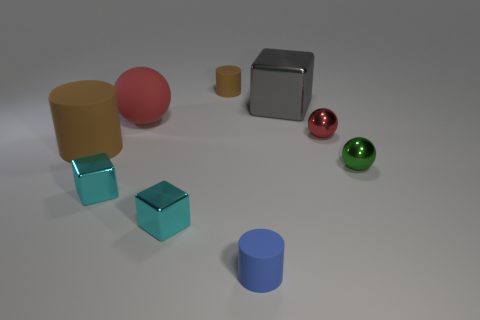Are there more things that are to the left of the red metal sphere than small brown matte cylinders?
Your answer should be very brief. Yes. Is the shape of the gray object the same as the big matte object that is behind the tiny red ball?
Your answer should be compact. No. The red metal object that is the same shape as the tiny green shiny thing is what size?
Your answer should be compact. Small. Are there more metallic objects than big gray metallic things?
Your answer should be very brief. Yes. Does the tiny red metallic thing have the same shape as the large gray object?
Make the answer very short. No. The tiny cylinder that is behind the metal sphere that is in front of the big matte cylinder is made of what material?
Make the answer very short. Rubber. There is a tiny object that is the same color as the large rubber cylinder; what material is it?
Offer a terse response. Rubber. Do the gray shiny cube and the blue object have the same size?
Provide a short and direct response. No. There is a red object that is left of the tiny brown cylinder; is there a small thing that is in front of it?
Ensure brevity in your answer.  Yes. There is a tiny rubber object that is in front of the big brown cylinder; what shape is it?
Give a very brief answer. Cylinder. 